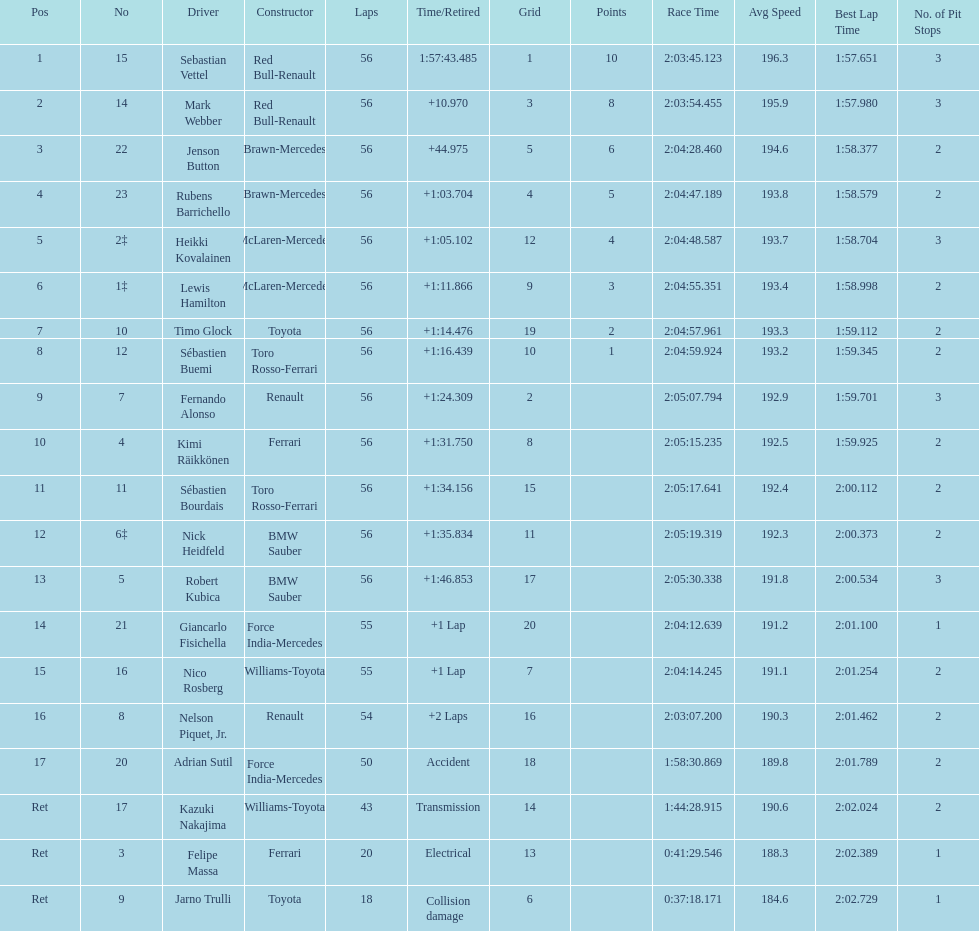Which driver is the only driver who retired because of collision damage? Jarno Trulli. 